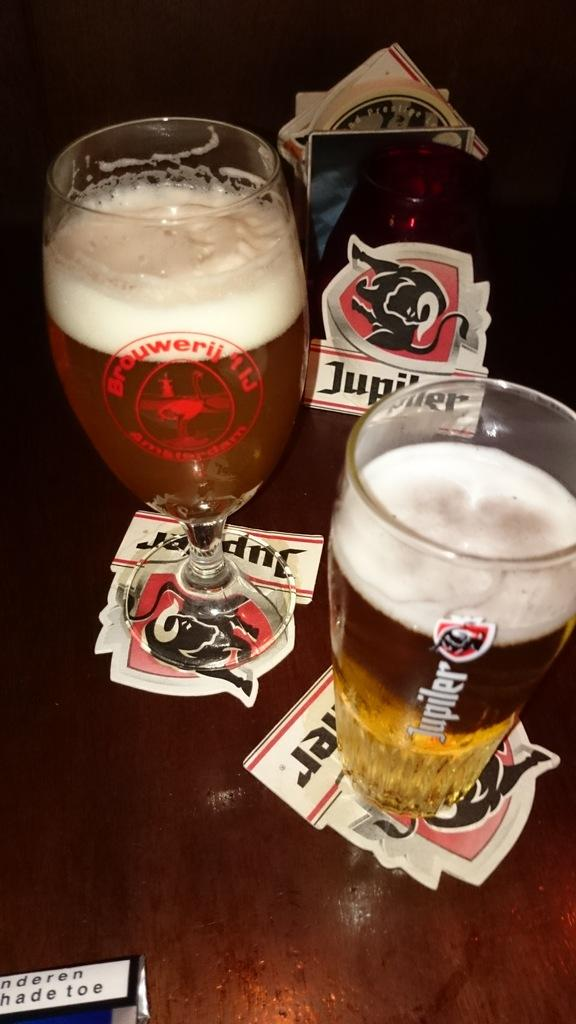<image>
Give a short and clear explanation of the subsequent image. Two beer glasses and coasters with one from Jupiler. 